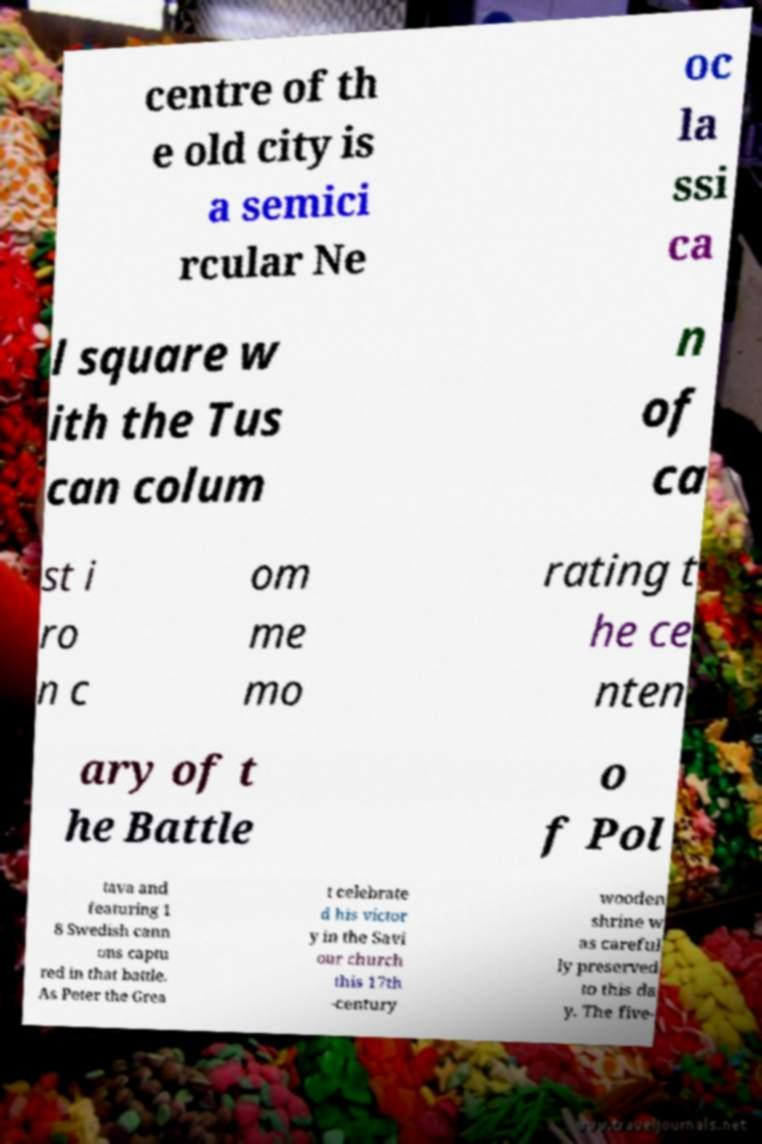Could you assist in decoding the text presented in this image and type it out clearly? centre of th e old city is a semici rcular Ne oc la ssi ca l square w ith the Tus can colum n of ca st i ro n c om me mo rating t he ce nten ary of t he Battle o f Pol tava and featuring 1 8 Swedish cann ons captu red in that battle. As Peter the Grea t celebrate d his victor y in the Savi our church this 17th -century wooden shrine w as careful ly preserved to this da y. The five- 